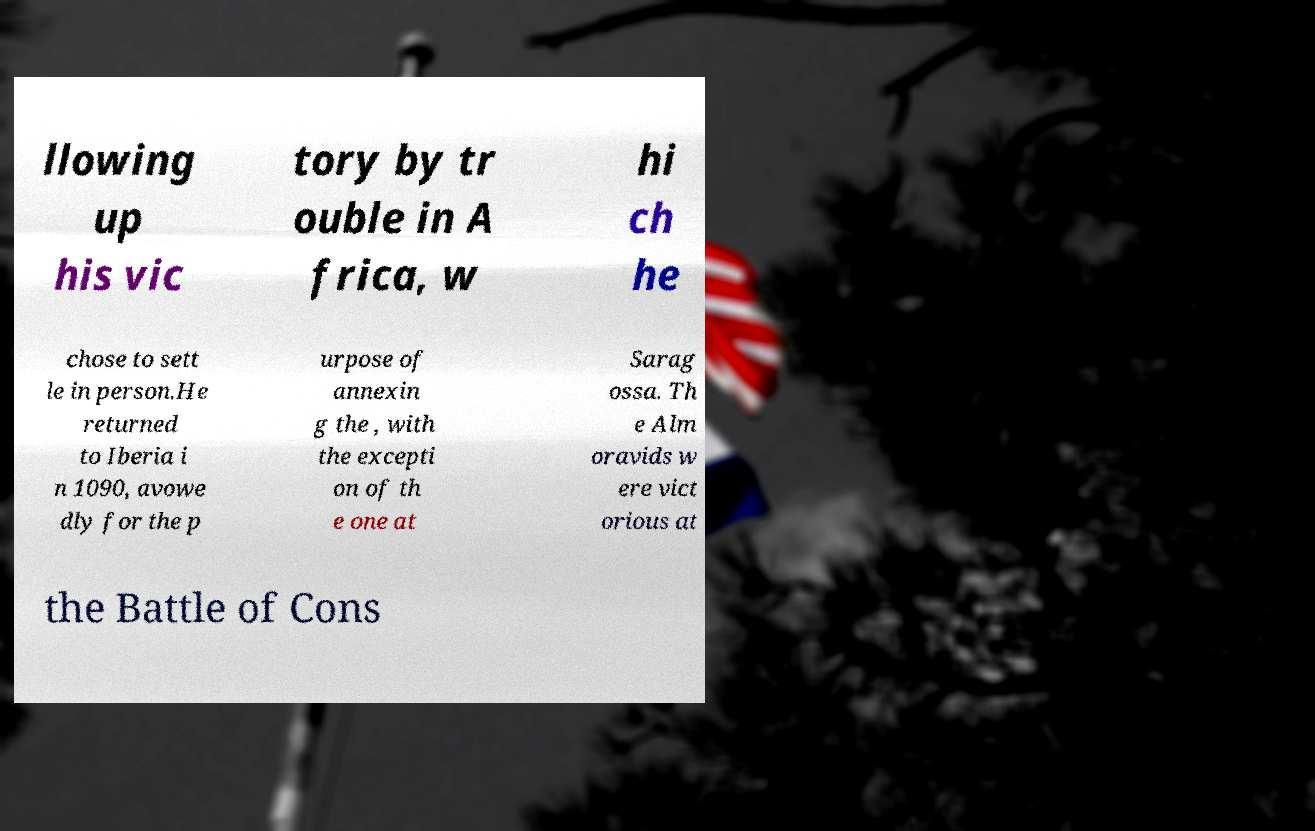I need the written content from this picture converted into text. Can you do that? llowing up his vic tory by tr ouble in A frica, w hi ch he chose to sett le in person.He returned to Iberia i n 1090, avowe dly for the p urpose of annexin g the , with the excepti on of th e one at Sarag ossa. Th e Alm oravids w ere vict orious at the Battle of Cons 